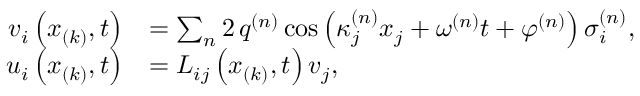Convert formula to latex. <formula><loc_0><loc_0><loc_500><loc_500>\begin{array} { r l } { v _ { i } \left ( x _ { ( k ) } , t \right ) } & { = \sum _ { n } 2 \, q ^ { ( n ) } \cos \left ( \kappa _ { j } ^ { ( n ) } x _ { j } + \omega ^ { ( n ) } t + \varphi ^ { ( n ) } \right ) \sigma _ { i } ^ { ( n ) } , } \\ { u _ { i } \left ( x _ { ( k ) } , t \right ) } & { = L _ { i j } \left ( x _ { ( k ) } , t \right ) v _ { j } , } \end{array}</formula> 